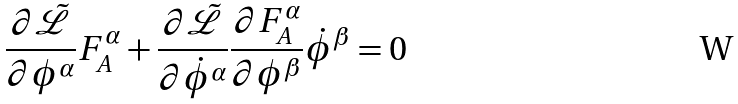<formula> <loc_0><loc_0><loc_500><loc_500>\frac { \partial { \tilde { \mathcal { L } } } } { \partial { \phi } ^ { \alpha } } F ^ { \alpha } _ { A } + \frac { \partial { \tilde { \mathcal { L } } } } { \partial { \dot { \phi } } ^ { \alpha } } \frac { \partial F ^ { \alpha } _ { A } } { \partial { \phi } ^ { \beta } } { \dot { \phi } } ^ { \beta } = 0</formula> 